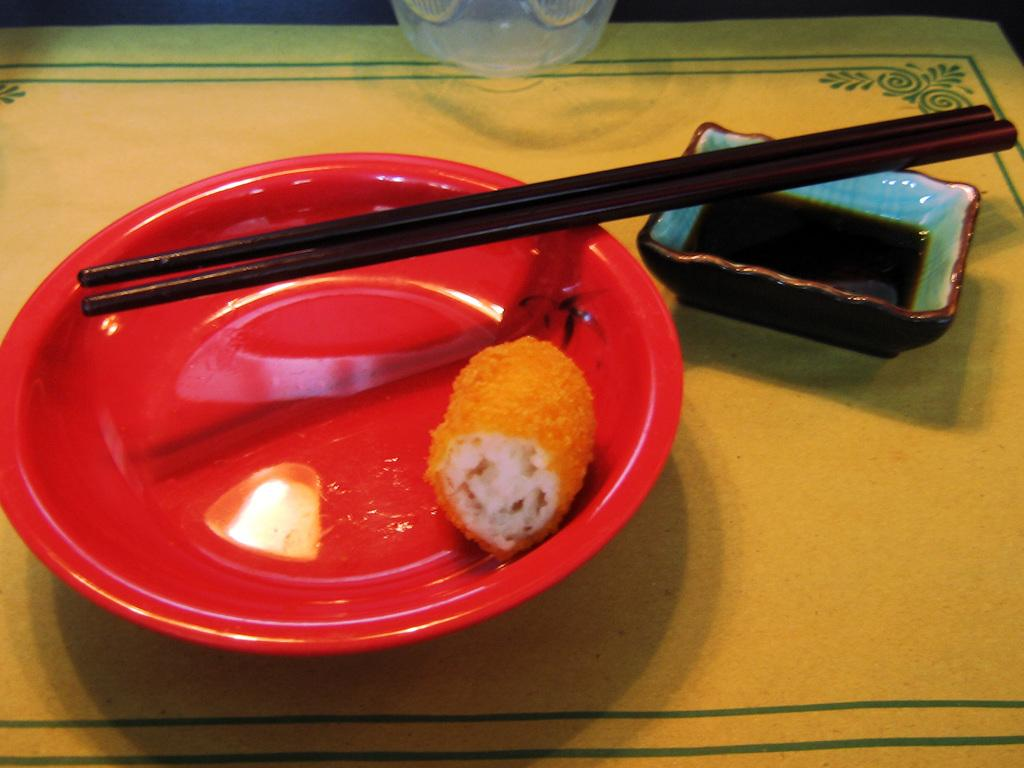What type of container is visible in the image? There is a glass in the image. What other type of container can be seen in the image? There is a bowl in the image. Are there any flat surfaces for serving food in the image? Yes, there is a plate in the image. What utensil is present in the image? There are chopsticks in the image. What type of ear is visible in the image? There is no ear present in the image. Can you tell me the cost of the meal based on the receipt in the image? There is no receipt present in the image. 